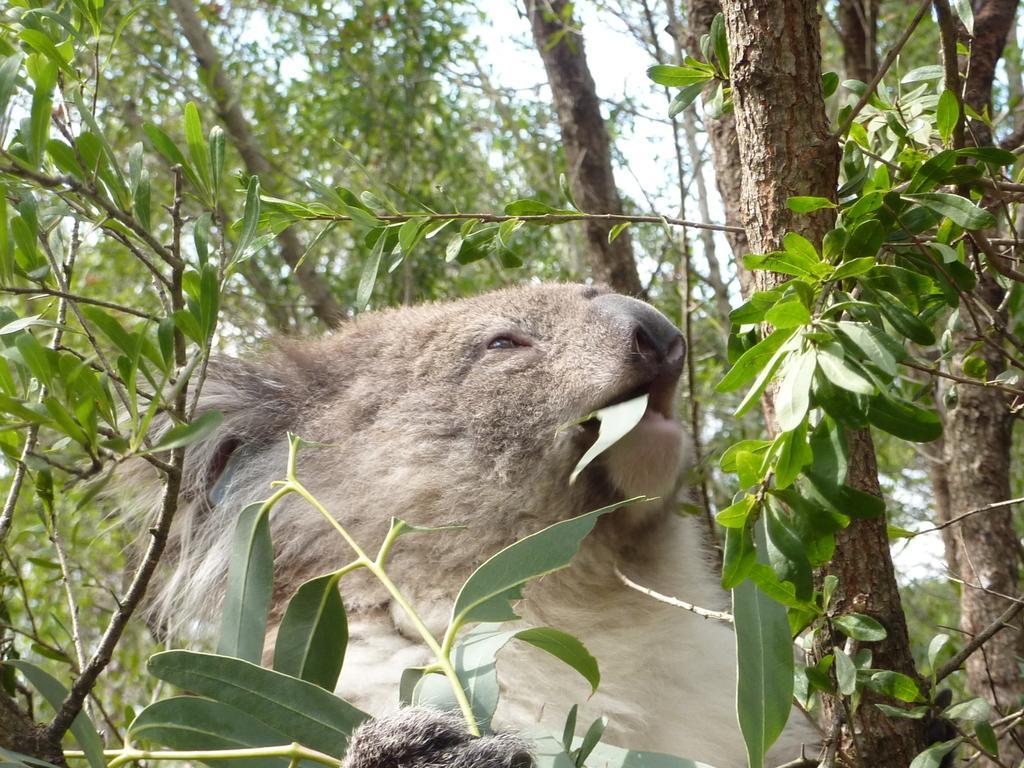Please provide a concise description of this image. In the image there is an animal. And also there are stems with branches and leaves. In the background there are trees. 